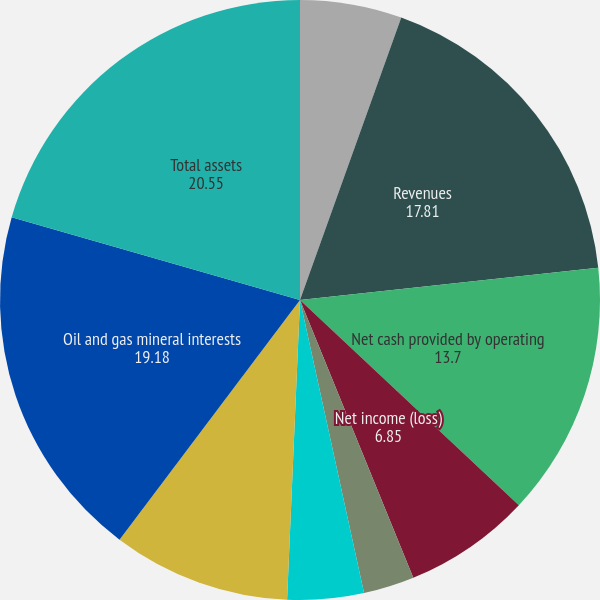Convert chart. <chart><loc_0><loc_0><loc_500><loc_500><pie_chart><fcel>(in thousands except per share<fcel>Revenues<fcel>Net cash provided by operating<fcel>Net income (loss)<fcel>Basic earnings (loss) per<fcel>Cash dividends<fcel>Year-end stock price<fcel>Basic weighted average shares<fcel>Oil and gas mineral interests<fcel>Total assets<nl><fcel>5.48%<fcel>17.81%<fcel>13.7%<fcel>6.85%<fcel>2.74%<fcel>0.0%<fcel>4.11%<fcel>9.59%<fcel>19.18%<fcel>20.55%<nl></chart> 